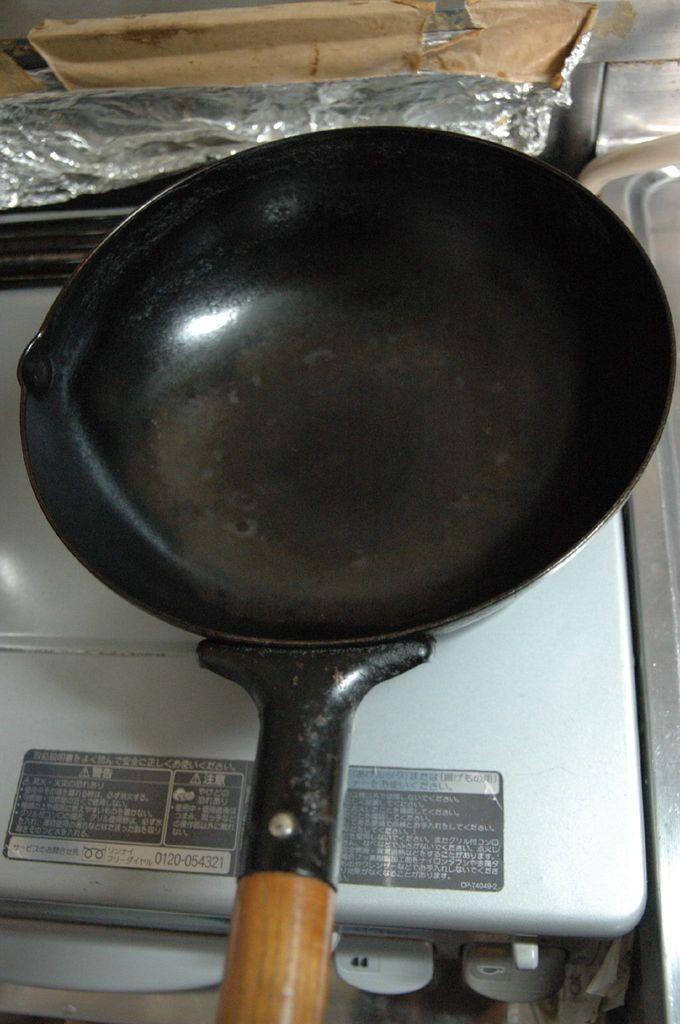In one or two sentences, can you explain what this image depicts? In this image we can see a pan on the stove. In the background of the image there is a silver foil. 